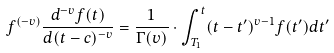Convert formula to latex. <formula><loc_0><loc_0><loc_500><loc_500>f ^ { \left ( - v \right ) } \frac { d ^ { - v } { f ( t ) } } { d ( t - c ) ^ { - v } } = \frac { 1 } { \Gamma ( v ) } \cdot \int _ { T _ { 1 } } ^ { t } ( t - t ^ { \prime } ) ^ { v - 1 } f ( t ^ { \prime } ) d t ^ { \prime }</formula> 